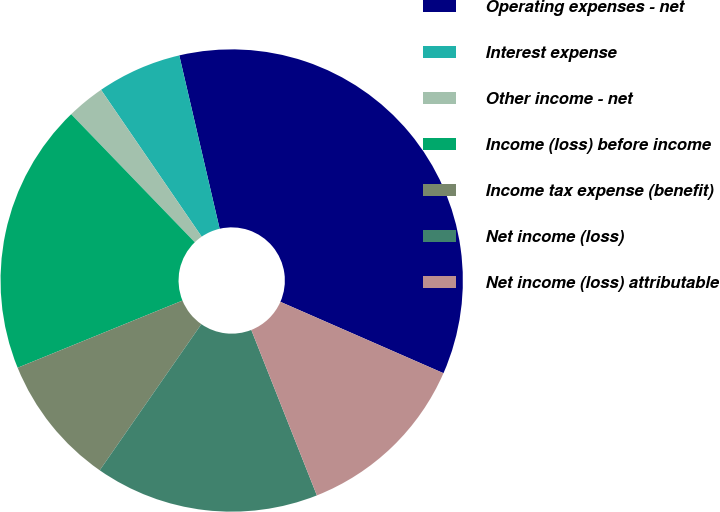Convert chart to OTSL. <chart><loc_0><loc_0><loc_500><loc_500><pie_chart><fcel>Operating expenses - net<fcel>Interest expense<fcel>Other income - net<fcel>Income (loss) before income<fcel>Income tax expense (benefit)<fcel>Net income (loss)<fcel>Net income (loss) attributable<nl><fcel>35.21%<fcel>5.92%<fcel>2.66%<fcel>18.94%<fcel>9.17%<fcel>15.68%<fcel>12.43%<nl></chart> 